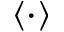<formula> <loc_0><loc_0><loc_500><loc_500>\langle \cdot \rangle</formula> 